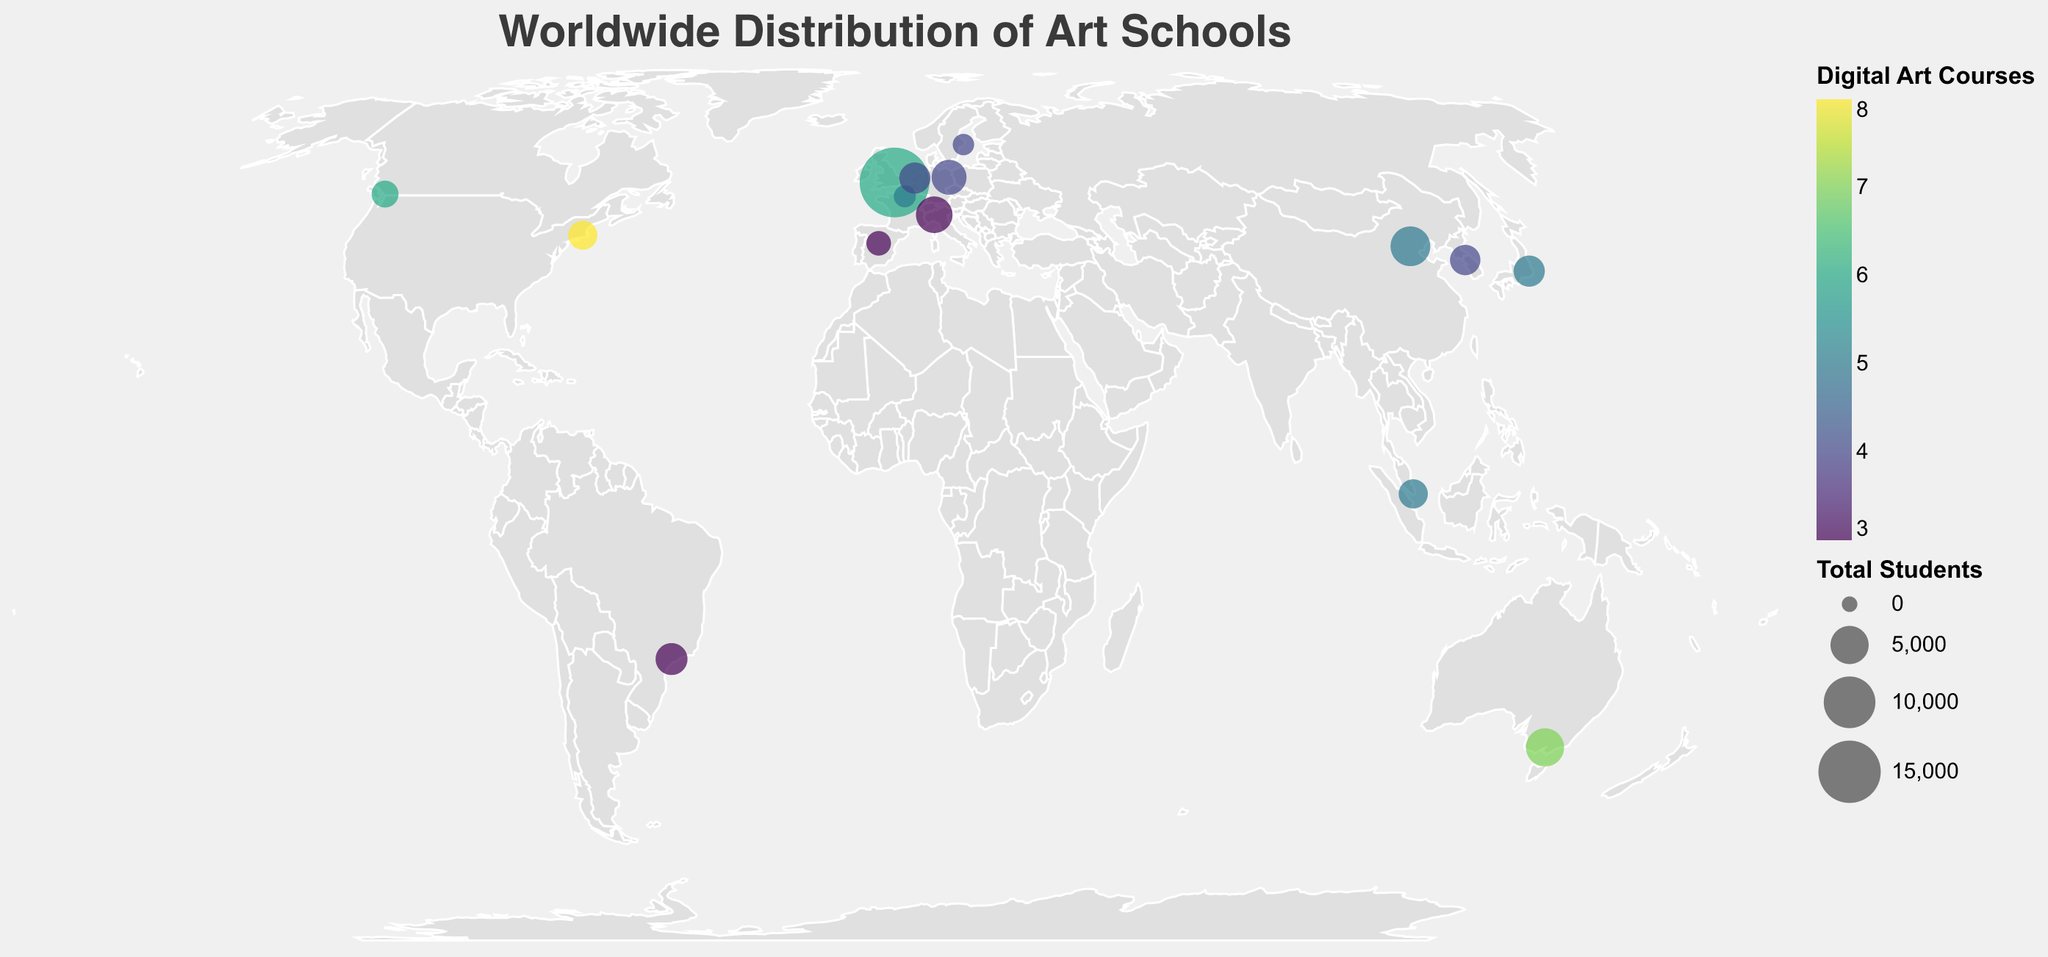What is the title of the geographic plot? The title of the geographic plot can typically be found at the top of the figure where it provides an overview of what the plot is about. In this case, it reads "Worldwide Distribution of Art Schools".
Answer: Worldwide Distribution of Art Schools Which country has the art school with the highest number of students enrolled in specialized digital art and financial management courses? By looking at the size of the circles, which indicate the number of students, the largest circle corresponds to the University of the Arts London in the United Kingdom.
Answer: United Kingdom How many art schools in total are represented in the geographic plot? Each circle represents an art school, and counting all the circles will give the total number of schools represented. From the data provided, we count 15 data points or circles.
Answer: 15 Which school offers the most digital art courses? Referring to the color intensity of the circles, the school with the brightest circle offers the most digital art courses. The data shows that Rhode Island School of Design in the United States offers 8 courses.
Answer: Rhode Island School of Design What is the range of the total number of students among all the represented schools? To find the range, we identify the smallest and largest values in the total number of students and subtract the smallest from the largest. The smallest value is 900 students (Konstfack University of Arts, Sweden), and the largest value is 19000 students (University of the Arts London, UK), so the range is 19000 - 900.
Answer: 18100 Which country in Asia has the art school with the most digital art courses? By filtering through the Asian countries and comparing the number of digital art courses, it is found that Singapore's LASALLE College of the Arts and China's China Central Academy of Fine Arts both offer 5 digital art courses each.
Answer: Singapore and China How does the number of digital art courses offered by RMIT University in Australia compare to that offered by Emily Carr University of Art + Design in Canada? RMIT University offers 7 digital art courses, while Emily Carr University of Art + Design offers 6. Thus, RMIT University offers more digital art courses by one.
Answer: RMIT University offers one more digital art course Calculate the average number of financial management courses offered by the art schools in Europe. To find this average, we consider the data for European schools: University of the Arts London (2), Berlin University of the Arts (2), Gobelins School of Visual Arts (1), ArtEZ University of the Arts (2), Nuova Accademia di Belle Arti (1), and ESNE School of Design (2). Summing these values gives 10, and there are 6 schools, so the average is 10/6.
Answer: 1.67 Which art school offers the fewest courses in both digital art and financial management? Referencing the data, the Universidade de São Paulo in Brazil and Nuova Accademia di Belle Arti in Italy each offer 3 digital art courses and 1 financial management course, the fewest among the schools listed.
Answer: Universidade de São Paulo and Nuova Accademia di Belle Arti How is the geographic plot color-coded to represent the number of digital art courses? The plot uses a color scale where the intensity or shade of the color represents the number of digital art courses offered by each school, with brighter colors indicating more courses.
Answer: Color shade intensity 